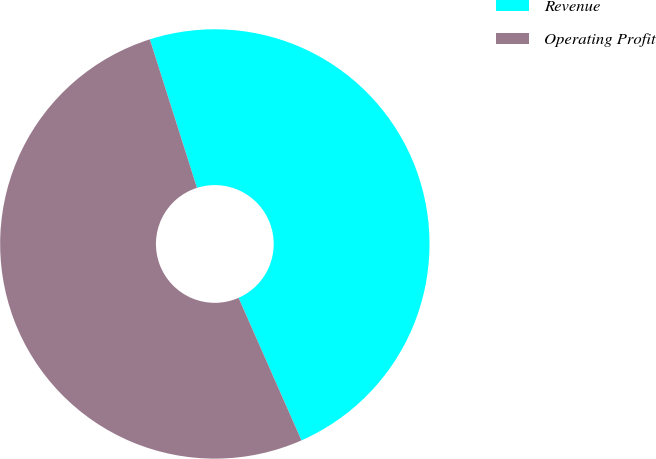Convert chart to OTSL. <chart><loc_0><loc_0><loc_500><loc_500><pie_chart><fcel>Revenue<fcel>Operating Profit<nl><fcel>48.28%<fcel>51.72%<nl></chart> 